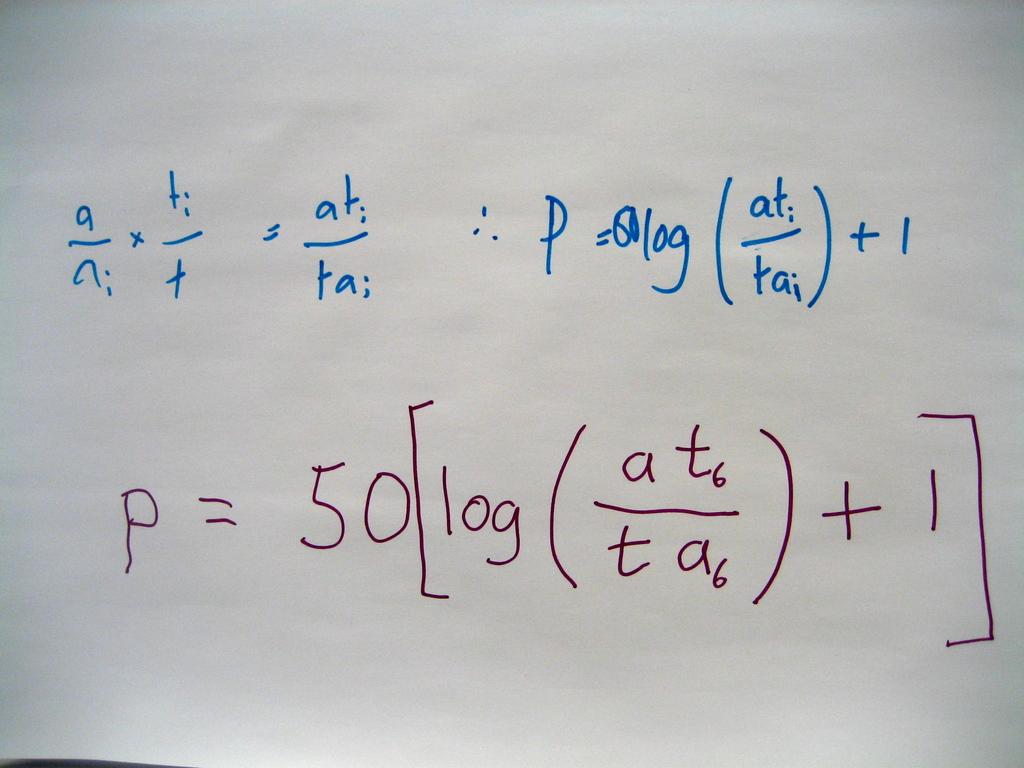What number is added at the end of this equation?
Keep it short and to the point. 1. 